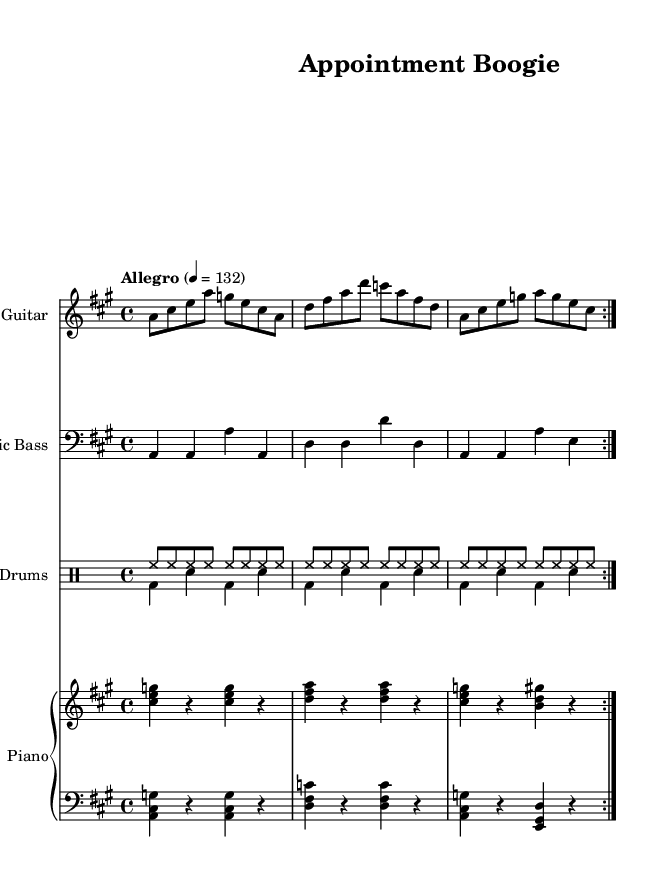What is the key signature of this music? The key signature is A major, which has three sharps: F sharp, C sharp, and G sharp.
Answer: A major What is the time signature of this music? The time signature is 4/4, indicating there are four beats in each measure and the quarter note gets one beat.
Answer: 4/4 What is the tempo marking given in the music? The tempo marking is Allegro at a speed of 132 beats per minute, suggesting a lively and fast-paced performance.
Answer: Allegro 132 How many measures are there in the repeated section of the electric guitar? The electric guitar part repeats twice and each repeat contains four measures, totaling eight measures.
Answer: Eight What is the primary rhythm style used in the drumming? The drumming features a shuffle rhythm, common in electric blues, characterized by swung eighth notes and a steady backbeat on the snare.
Answer: Shuffle What characterizes the chord progression in the piano part? The chord progression follows a typical blues pattern, alternating between the I, IV, and V chords of the key, structured to maintain the blues feel.
Answer: Blues pattern What instruments are included in the score? The score includes electric guitar, electric bass, drums, and piano, forming a classic electric blues ensemble.
Answer: Electric guitar, electric bass, drums, piano 